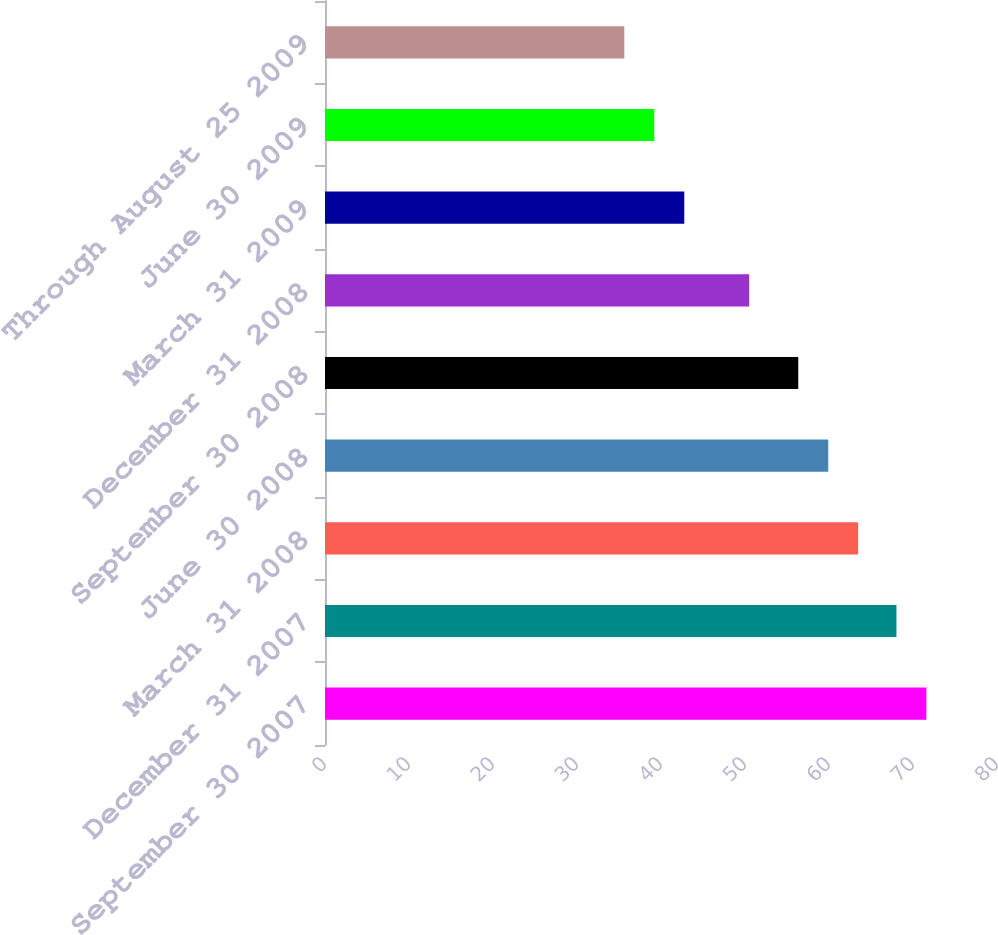Convert chart to OTSL. <chart><loc_0><loc_0><loc_500><loc_500><bar_chart><fcel>September 30 2007<fcel>December 31 2007<fcel>March 31 2008<fcel>June 30 2008<fcel>September 30 2008<fcel>December 31 2008<fcel>March 31 2009<fcel>June 30 2009<fcel>Through August 25 2009<nl><fcel>71.59<fcel>68.03<fcel>63.47<fcel>59.91<fcel>56.34<fcel>50.5<fcel>42.77<fcel>39.2<fcel>35.63<nl></chart> 